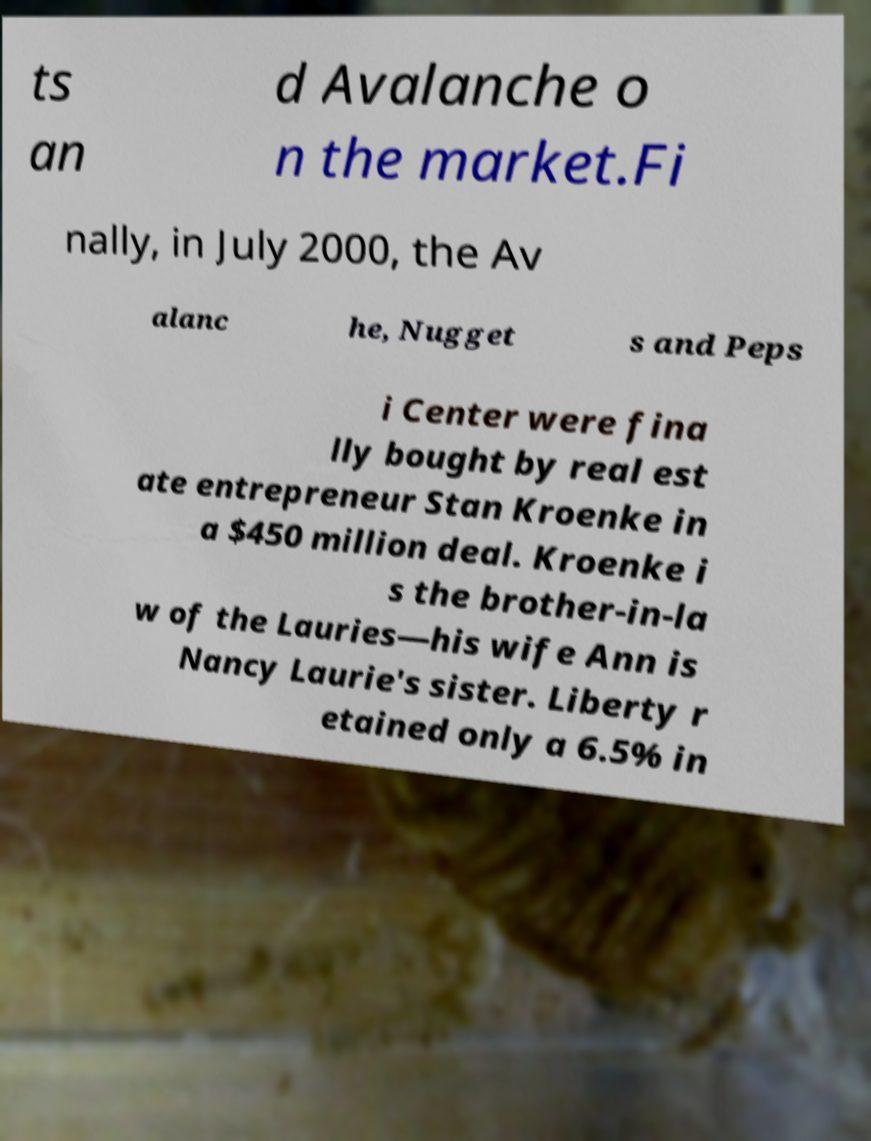What messages or text are displayed in this image? I need them in a readable, typed format. ts an d Avalanche o n the market.Fi nally, in July 2000, the Av alanc he, Nugget s and Peps i Center were fina lly bought by real est ate entrepreneur Stan Kroenke in a $450 million deal. Kroenke i s the brother-in-la w of the Lauries—his wife Ann is Nancy Laurie's sister. Liberty r etained only a 6.5% in 